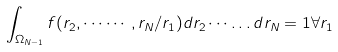<formula> <loc_0><loc_0><loc_500><loc_500>\int _ { \Omega _ { N - 1 } } f ( { r } _ { 2 } , \cdots \cdots , { r } _ { N } / { r } _ { 1 } ) d { r } _ { 2 } \cdots \dots d { r } _ { N } = 1 \forall { r } _ { 1 }</formula> 